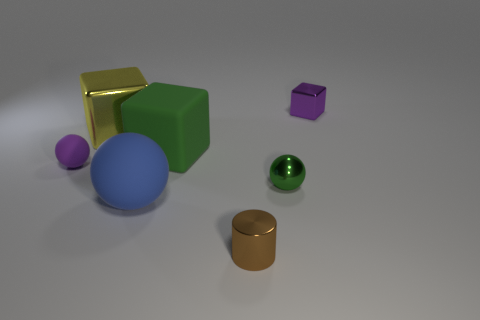What is the color of the tiny thing that is made of the same material as the big green block?
Make the answer very short. Purple. How many metal blocks are the same size as the purple rubber thing?
Your response must be concise. 1. Do the tiny sphere that is on the left side of the big blue rubber thing and the tiny purple block have the same material?
Keep it short and to the point. No. Are there fewer small brown metallic objects in front of the big yellow shiny block than objects?
Provide a succinct answer. Yes. There is a green object that is in front of the purple matte object; what shape is it?
Keep it short and to the point. Sphere. There is a matte thing that is the same size as the green metal object; what is its shape?
Provide a succinct answer. Sphere. Are there any gray matte objects of the same shape as the small purple metal thing?
Your answer should be very brief. No. Does the purple thing that is on the right side of the purple ball have the same shape as the big shiny object on the left side of the tiny brown thing?
Keep it short and to the point. Yes. There is a purple ball that is the same size as the brown metal thing; what is its material?
Your response must be concise. Rubber. How many other objects are the same material as the large ball?
Keep it short and to the point. 2. 